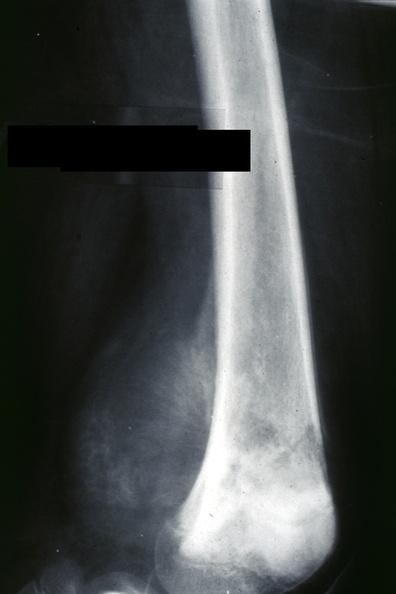what is slide?
Answer the question using a single word or phrase. Ap view 